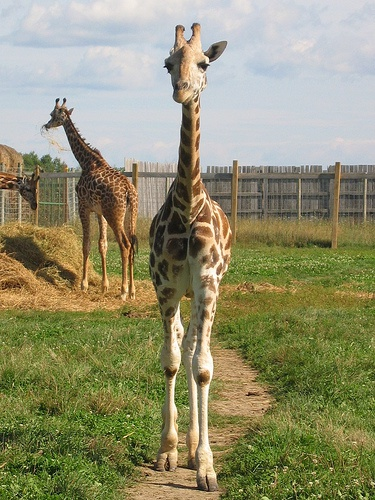Describe the objects in this image and their specific colors. I can see giraffe in lightgray, olive, black, gray, and beige tones, giraffe in lightgray, maroon, black, and tan tones, and giraffe in lightgray, black, maroon, and gray tones in this image. 